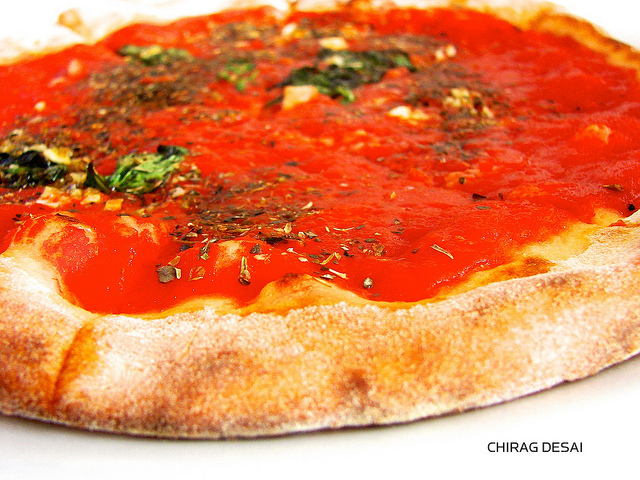Identify the text displayed in this image. CHIRAG DESAI 